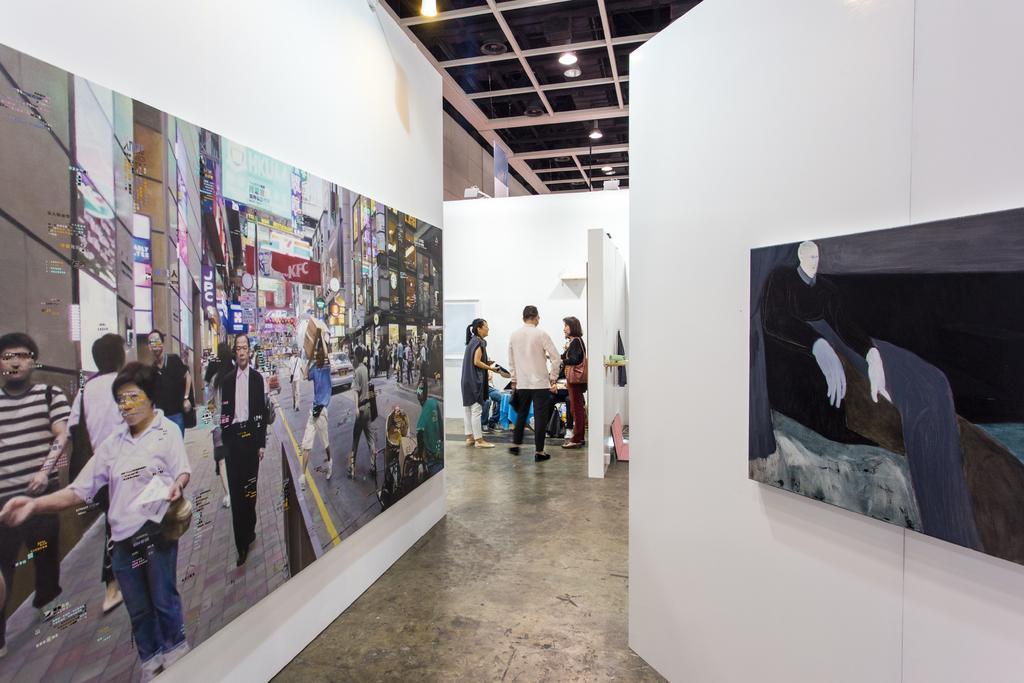Can you describe this image briefly? In this image we can see the inner view of a building. In this image we can see people, bag, wall and other objects. On the left and right side of the image there is a wall with photocopies. At the top of the image there is the ceiling with lights and other objects. At the bottom of the image there is the floor. 